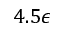Convert formula to latex. <formula><loc_0><loc_0><loc_500><loc_500>4 . 5 \epsilon</formula> 